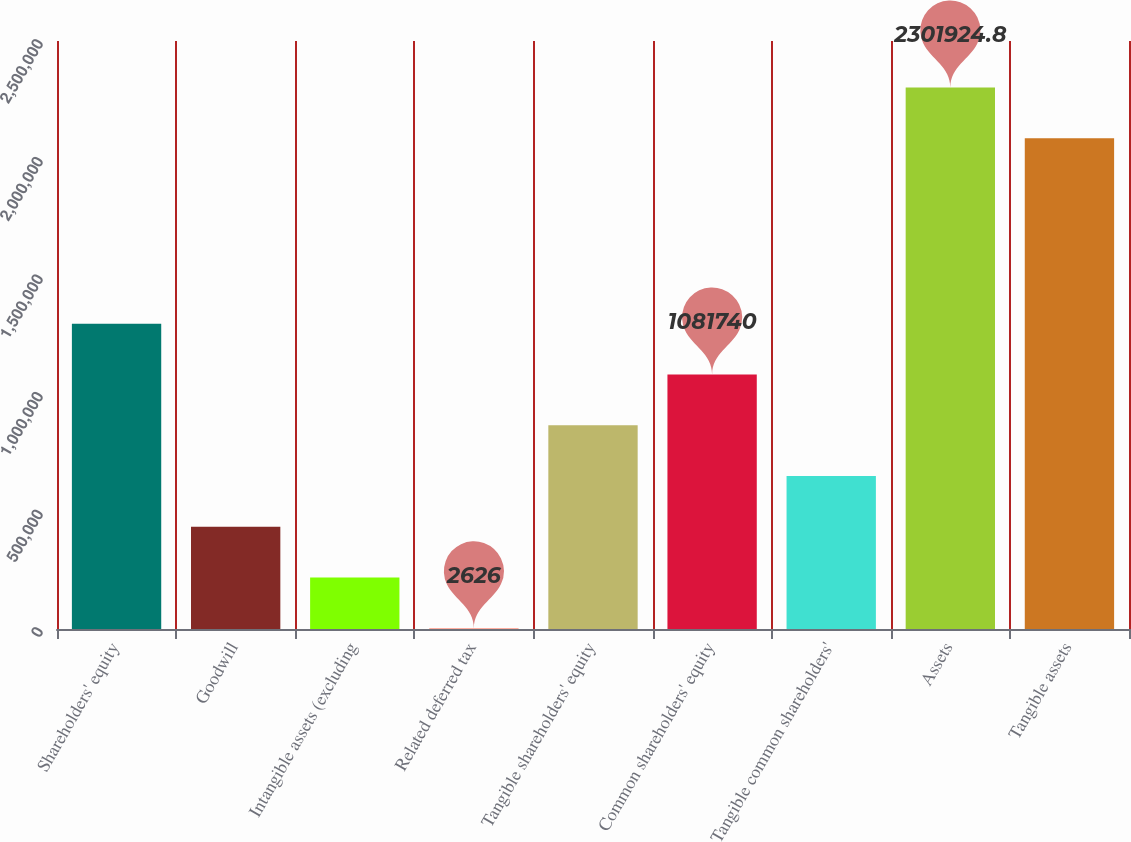Convert chart. <chart><loc_0><loc_0><loc_500><loc_500><bar_chart><fcel>Shareholders' equity<fcel>Goodwill<fcel>Intangible assets (excluding<fcel>Related deferred tax<fcel>Tangible shareholders' equity<fcel>Common shareholders' equity<fcel>Tangible common shareholders'<fcel>Assets<fcel>Tangible assets<nl><fcel>1.29756e+06<fcel>434272<fcel>218449<fcel>2626<fcel>865917<fcel>1.08174e+06<fcel>650094<fcel>2.30192e+06<fcel>2.0861e+06<nl></chart> 